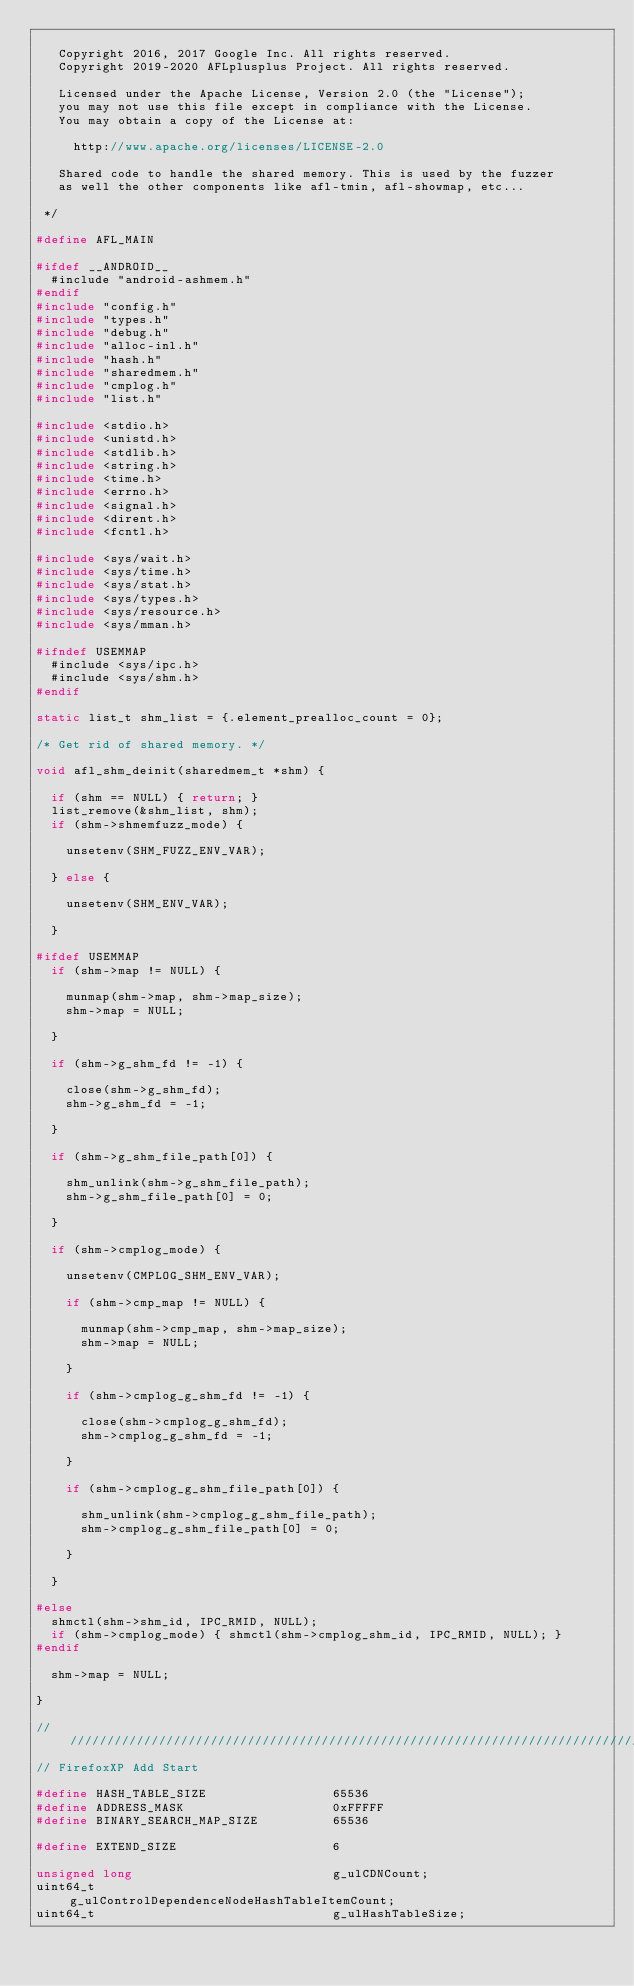<code> <loc_0><loc_0><loc_500><loc_500><_C_>
   Copyright 2016, 2017 Google Inc. All rights reserved.
   Copyright 2019-2020 AFLplusplus Project. All rights reserved.

   Licensed under the Apache License, Version 2.0 (the "License");
   you may not use this file except in compliance with the License.
   You may obtain a copy of the License at:

     http://www.apache.org/licenses/LICENSE-2.0

   Shared code to handle the shared memory. This is used by the fuzzer
   as well the other components like afl-tmin, afl-showmap, etc...

 */

#define AFL_MAIN

#ifdef __ANDROID__
  #include "android-ashmem.h"
#endif
#include "config.h"
#include "types.h"
#include "debug.h"
#include "alloc-inl.h"
#include "hash.h"
#include "sharedmem.h"
#include "cmplog.h"
#include "list.h"

#include <stdio.h>
#include <unistd.h>
#include <stdlib.h>
#include <string.h>
#include <time.h>
#include <errno.h>
#include <signal.h>
#include <dirent.h>
#include <fcntl.h>

#include <sys/wait.h>
#include <sys/time.h>
#include <sys/stat.h>
#include <sys/types.h>
#include <sys/resource.h>
#include <sys/mman.h>

#ifndef USEMMAP
  #include <sys/ipc.h>
  #include <sys/shm.h>
#endif

static list_t shm_list = {.element_prealloc_count = 0};

/* Get rid of shared memory. */

void afl_shm_deinit(sharedmem_t *shm) {

  if (shm == NULL) { return; }
  list_remove(&shm_list, shm);
  if (shm->shmemfuzz_mode) {

    unsetenv(SHM_FUZZ_ENV_VAR);

  } else {

    unsetenv(SHM_ENV_VAR);

  }

#ifdef USEMMAP
  if (shm->map != NULL) {

    munmap(shm->map, shm->map_size);
    shm->map = NULL;

  }

  if (shm->g_shm_fd != -1) {

    close(shm->g_shm_fd);
    shm->g_shm_fd = -1;

  }

  if (shm->g_shm_file_path[0]) {

    shm_unlink(shm->g_shm_file_path);
    shm->g_shm_file_path[0] = 0;

  }

  if (shm->cmplog_mode) {

    unsetenv(CMPLOG_SHM_ENV_VAR);

    if (shm->cmp_map != NULL) {

      munmap(shm->cmp_map, shm->map_size);
      shm->map = NULL;

    }

    if (shm->cmplog_g_shm_fd != -1) {

      close(shm->cmplog_g_shm_fd);
      shm->cmplog_g_shm_fd = -1;

    }

    if (shm->cmplog_g_shm_file_path[0]) {

      shm_unlink(shm->cmplog_g_shm_file_path);
      shm->cmplog_g_shm_file_path[0] = 0;

    }

  }

#else
  shmctl(shm->shm_id, IPC_RMID, NULL);
  if (shm->cmplog_mode) { shmctl(shm->cmplog_shm_id, IPC_RMID, NULL); }
#endif

  shm->map = NULL;

}

//////////////////////////////////////////////////////////////////////////////////////////////////////////
// FirefoxXP Add Start

#define HASH_TABLE_SIZE		              65536
#define ADDRESS_MASK		                0xFFFFF
#define BINARY_SEARCH_MAP_SIZE          65536

#define EXTEND_SIZE                     6

unsigned long							              g_ulCDNCount;
uint64_t								                g_ulControlDependenceNodeHashTableItemCount;
uint64_t                                g_ulHashTableSize;</code> 